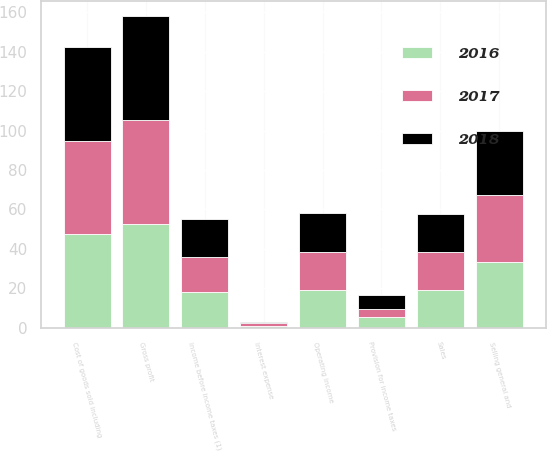<chart> <loc_0><loc_0><loc_500><loc_500><stacked_bar_chart><ecel><fcel>Sales<fcel>Cost of goods sold including<fcel>Gross profit<fcel>Selling general and<fcel>Operating income<fcel>Interest expense<fcel>Income before income taxes (1)<fcel>Provision for income taxes<nl><fcel>2017<fcel>19.2<fcel>47.2<fcel>52.8<fcel>33.8<fcel>19<fcel>1.3<fcel>17.8<fcel>3.9<nl><fcel>2016<fcel>19.2<fcel>47.4<fcel>52.6<fcel>33.4<fcel>19.2<fcel>1<fcel>18.2<fcel>5.6<nl><fcel>2018<fcel>19.2<fcel>47.5<fcel>52.5<fcel>32.7<fcel>19.8<fcel>0.8<fcel>19.1<fcel>7<nl></chart> 